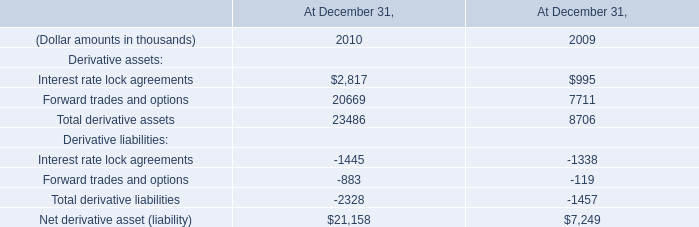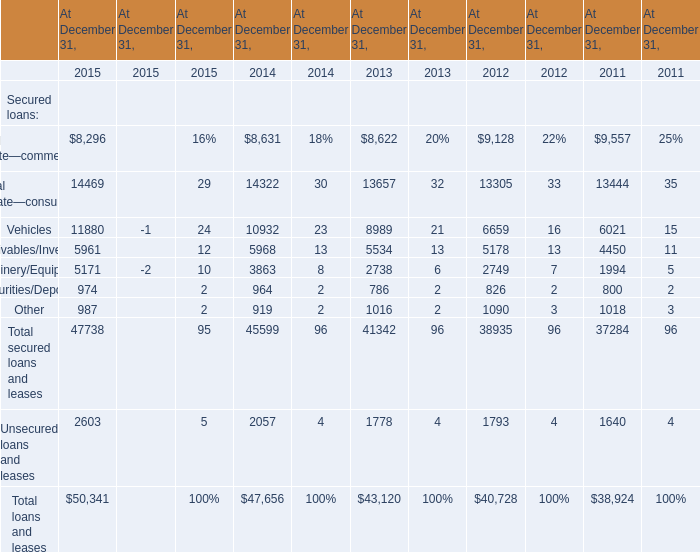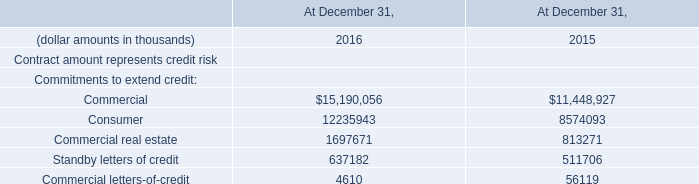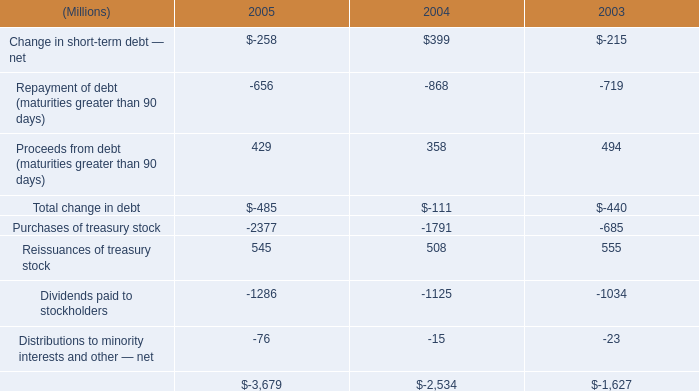What is the average amount of Commercial of At December 31, 2016, and Purchases of treasury stock of 2004 ? 
Computations: ((15190056.0 + 1791.0) / 2)
Answer: 7595923.5. 